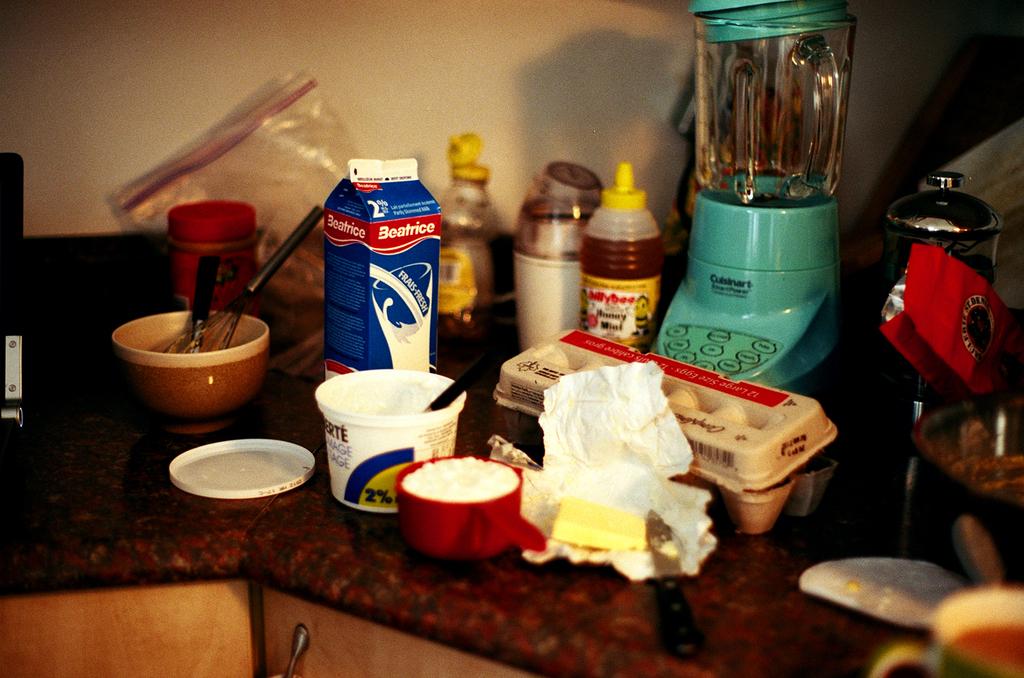What brand of milk is shown?
Your answer should be very brief. Beatrice. What brand of honey is in the yellow bottle?
Your answer should be very brief. Billy bee. 